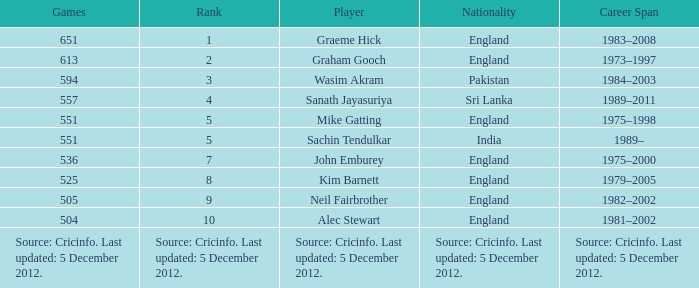What is the nationality of the player who played 505 games? England. 